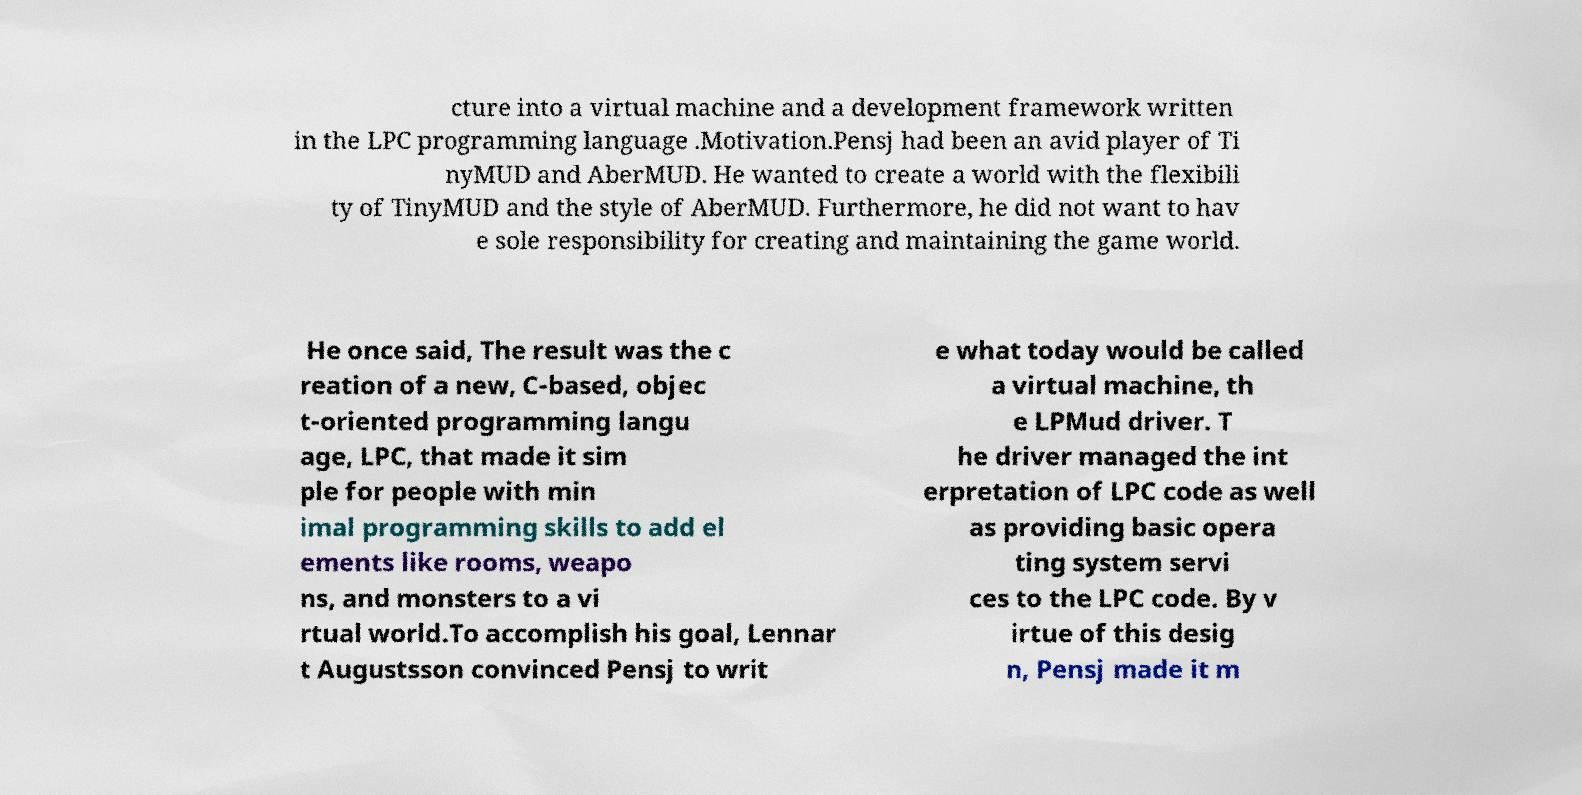Can you read and provide the text displayed in the image?This photo seems to have some interesting text. Can you extract and type it out for me? cture into a virtual machine and a development framework written in the LPC programming language .Motivation.Pensj had been an avid player of Ti nyMUD and AberMUD. He wanted to create a world with the flexibili ty of TinyMUD and the style of AberMUD. Furthermore, he did not want to hav e sole responsibility for creating and maintaining the game world. He once said, The result was the c reation of a new, C-based, objec t-oriented programming langu age, LPC, that made it sim ple for people with min imal programming skills to add el ements like rooms, weapo ns, and monsters to a vi rtual world.To accomplish his goal, Lennar t Augustsson convinced Pensj to writ e what today would be called a virtual machine, th e LPMud driver. T he driver managed the int erpretation of LPC code as well as providing basic opera ting system servi ces to the LPC code. By v irtue of this desig n, Pensj made it m 